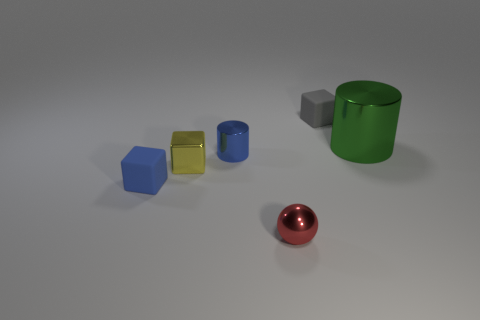Add 4 tiny blue matte blocks. How many objects exist? 10 Subtract all cylinders. How many objects are left? 4 Subtract 1 gray blocks. How many objects are left? 5 Subtract all small cylinders. Subtract all blue objects. How many objects are left? 3 Add 3 large metallic cylinders. How many large metallic cylinders are left? 4 Add 6 big purple cylinders. How many big purple cylinders exist? 6 